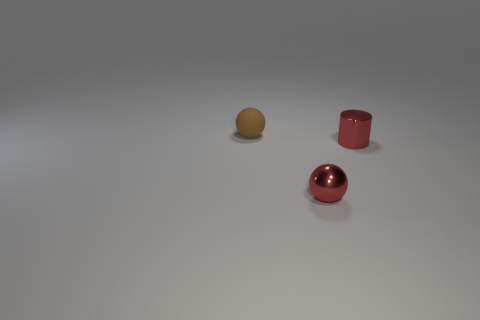Are there fewer small metallic cylinders than red metallic things?
Give a very brief answer. Yes. There is a small red metallic object that is in front of the cylinder; is its shape the same as the tiny object that is behind the red metal cylinder?
Your response must be concise. Yes. What number of objects are either cyan matte cylinders or matte things?
Provide a succinct answer. 1. There is a metal ball that is the same size as the red cylinder; what color is it?
Your answer should be very brief. Red. There is a red metal thing on the right side of the red ball; what number of balls are behind it?
Provide a succinct answer. 1. What number of things are behind the small cylinder and on the right side of the tiny brown ball?
Provide a short and direct response. 0. How many things are either spheres that are on the right side of the tiny matte sphere or balls that are right of the small brown rubber thing?
Provide a succinct answer. 1. What shape is the object that is on the right side of the red metal thing that is to the left of the red metallic cylinder?
Ensure brevity in your answer.  Cylinder. There is a object that is in front of the small metal cylinder; does it have the same color as the metal thing that is behind the red sphere?
Make the answer very short. Yes. Is there anything else that is the same color as the small matte object?
Offer a terse response. No. 